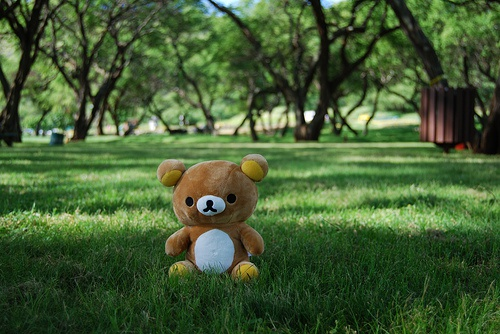Describe the objects in this image and their specific colors. I can see a teddy bear in darkgreen, olive, maroon, black, and gray tones in this image. 